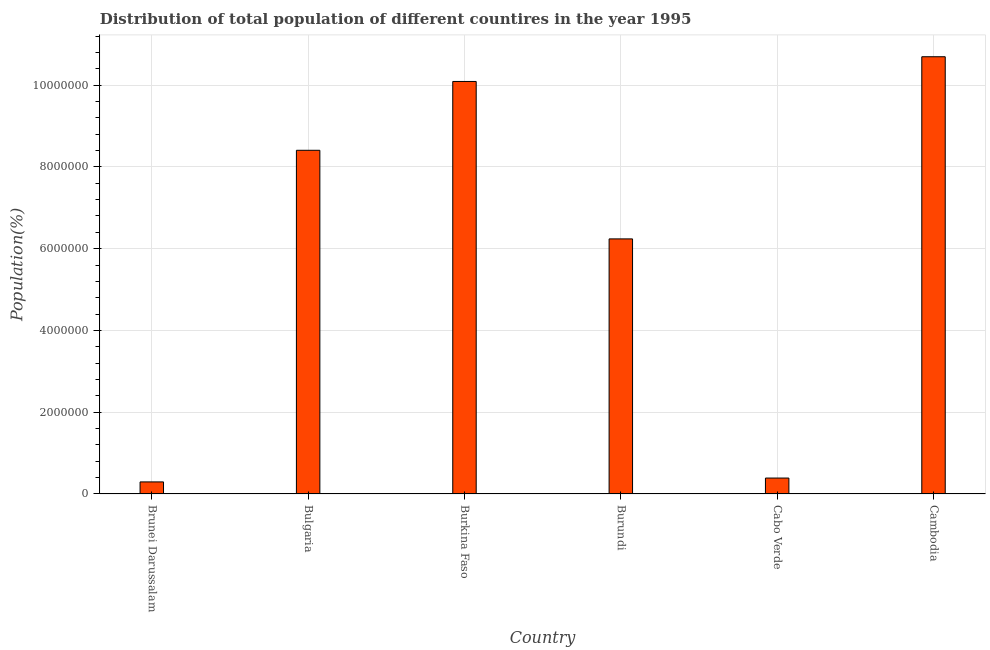What is the title of the graph?
Keep it short and to the point. Distribution of total population of different countires in the year 1995. What is the label or title of the X-axis?
Ensure brevity in your answer.  Country. What is the label or title of the Y-axis?
Ensure brevity in your answer.  Population(%). What is the population in Cambodia?
Give a very brief answer. 1.07e+07. Across all countries, what is the maximum population?
Offer a terse response. 1.07e+07. Across all countries, what is the minimum population?
Ensure brevity in your answer.  2.95e+05. In which country was the population maximum?
Keep it short and to the point. Cambodia. In which country was the population minimum?
Provide a succinct answer. Brunei Darussalam. What is the sum of the population?
Your answer should be very brief. 3.61e+07. What is the difference between the population in Burkina Faso and Burundi?
Ensure brevity in your answer.  3.85e+06. What is the average population per country?
Keep it short and to the point. 6.02e+06. What is the median population?
Keep it short and to the point. 7.32e+06. In how many countries, is the population greater than 3600000 %?
Your response must be concise. 4. What is the ratio of the population in Burundi to that in Cabo Verde?
Offer a very short reply. 16.03. Is the population in Brunei Darussalam less than that in Bulgaria?
Provide a succinct answer. Yes. Is the difference between the population in Brunei Darussalam and Cambodia greater than the difference between any two countries?
Give a very brief answer. Yes. What is the difference between the highest and the second highest population?
Offer a terse response. 6.05e+05. What is the difference between the highest and the lowest population?
Provide a succinct answer. 1.04e+07. How many bars are there?
Provide a short and direct response. 6. How many countries are there in the graph?
Offer a terse response. 6. What is the difference between two consecutive major ticks on the Y-axis?
Offer a very short reply. 2.00e+06. What is the Population(%) of Brunei Darussalam?
Ensure brevity in your answer.  2.95e+05. What is the Population(%) of Bulgaria?
Your answer should be very brief. 8.41e+06. What is the Population(%) of Burkina Faso?
Give a very brief answer. 1.01e+07. What is the Population(%) of Burundi?
Your answer should be compact. 6.24e+06. What is the Population(%) in Cabo Verde?
Your response must be concise. 3.89e+05. What is the Population(%) in Cambodia?
Make the answer very short. 1.07e+07. What is the difference between the Population(%) in Brunei Darussalam and Bulgaria?
Provide a succinct answer. -8.11e+06. What is the difference between the Population(%) in Brunei Darussalam and Burkina Faso?
Give a very brief answer. -9.79e+06. What is the difference between the Population(%) in Brunei Darussalam and Burundi?
Offer a very short reply. -5.94e+06. What is the difference between the Population(%) in Brunei Darussalam and Cabo Verde?
Ensure brevity in your answer.  -9.41e+04. What is the difference between the Population(%) in Brunei Darussalam and Cambodia?
Your answer should be very brief. -1.04e+07. What is the difference between the Population(%) in Bulgaria and Burkina Faso?
Offer a terse response. -1.68e+06. What is the difference between the Population(%) in Bulgaria and Burundi?
Your answer should be very brief. 2.17e+06. What is the difference between the Population(%) in Bulgaria and Cabo Verde?
Your answer should be very brief. 8.02e+06. What is the difference between the Population(%) in Bulgaria and Cambodia?
Give a very brief answer. -2.29e+06. What is the difference between the Population(%) in Burkina Faso and Burundi?
Offer a very short reply. 3.85e+06. What is the difference between the Population(%) in Burkina Faso and Cabo Verde?
Provide a succinct answer. 9.70e+06. What is the difference between the Population(%) in Burkina Faso and Cambodia?
Provide a succinct answer. -6.05e+05. What is the difference between the Population(%) in Burundi and Cabo Verde?
Provide a succinct answer. 5.85e+06. What is the difference between the Population(%) in Burundi and Cambodia?
Your response must be concise. -4.46e+06. What is the difference between the Population(%) in Cabo Verde and Cambodia?
Provide a short and direct response. -1.03e+07. What is the ratio of the Population(%) in Brunei Darussalam to that in Bulgaria?
Your answer should be very brief. 0.04. What is the ratio of the Population(%) in Brunei Darussalam to that in Burkina Faso?
Give a very brief answer. 0.03. What is the ratio of the Population(%) in Brunei Darussalam to that in Burundi?
Your response must be concise. 0.05. What is the ratio of the Population(%) in Brunei Darussalam to that in Cabo Verde?
Ensure brevity in your answer.  0.76. What is the ratio of the Population(%) in Brunei Darussalam to that in Cambodia?
Provide a succinct answer. 0.03. What is the ratio of the Population(%) in Bulgaria to that in Burkina Faso?
Give a very brief answer. 0.83. What is the ratio of the Population(%) in Bulgaria to that in Burundi?
Your answer should be compact. 1.35. What is the ratio of the Population(%) in Bulgaria to that in Cabo Verde?
Your answer should be very brief. 21.6. What is the ratio of the Population(%) in Bulgaria to that in Cambodia?
Provide a short and direct response. 0.79. What is the ratio of the Population(%) in Burkina Faso to that in Burundi?
Your response must be concise. 1.62. What is the ratio of the Population(%) in Burkina Faso to that in Cabo Verde?
Your response must be concise. 25.93. What is the ratio of the Population(%) in Burkina Faso to that in Cambodia?
Give a very brief answer. 0.94. What is the ratio of the Population(%) in Burundi to that in Cabo Verde?
Your response must be concise. 16.03. What is the ratio of the Population(%) in Burundi to that in Cambodia?
Ensure brevity in your answer.  0.58. What is the ratio of the Population(%) in Cabo Verde to that in Cambodia?
Give a very brief answer. 0.04. 